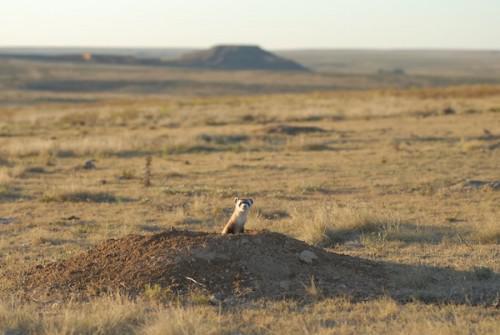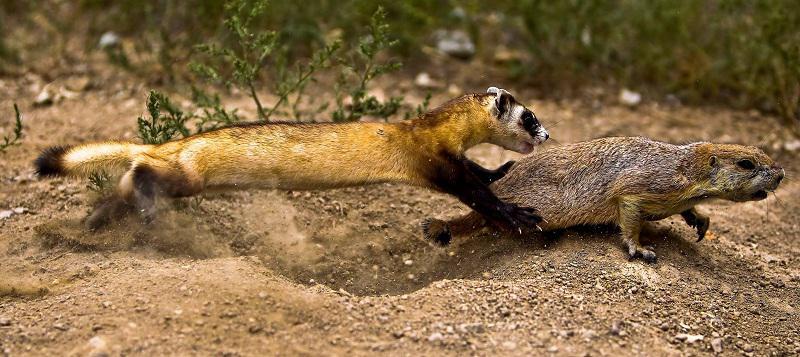The first image is the image on the left, the second image is the image on the right. Examine the images to the left and right. Is the description "There are 3 total ferrets." accurate? Answer yes or no. Yes. The first image is the image on the left, the second image is the image on the right. Evaluate the accuracy of this statement regarding the images: "There are two ferrets total.". Is it true? Answer yes or no. No. 